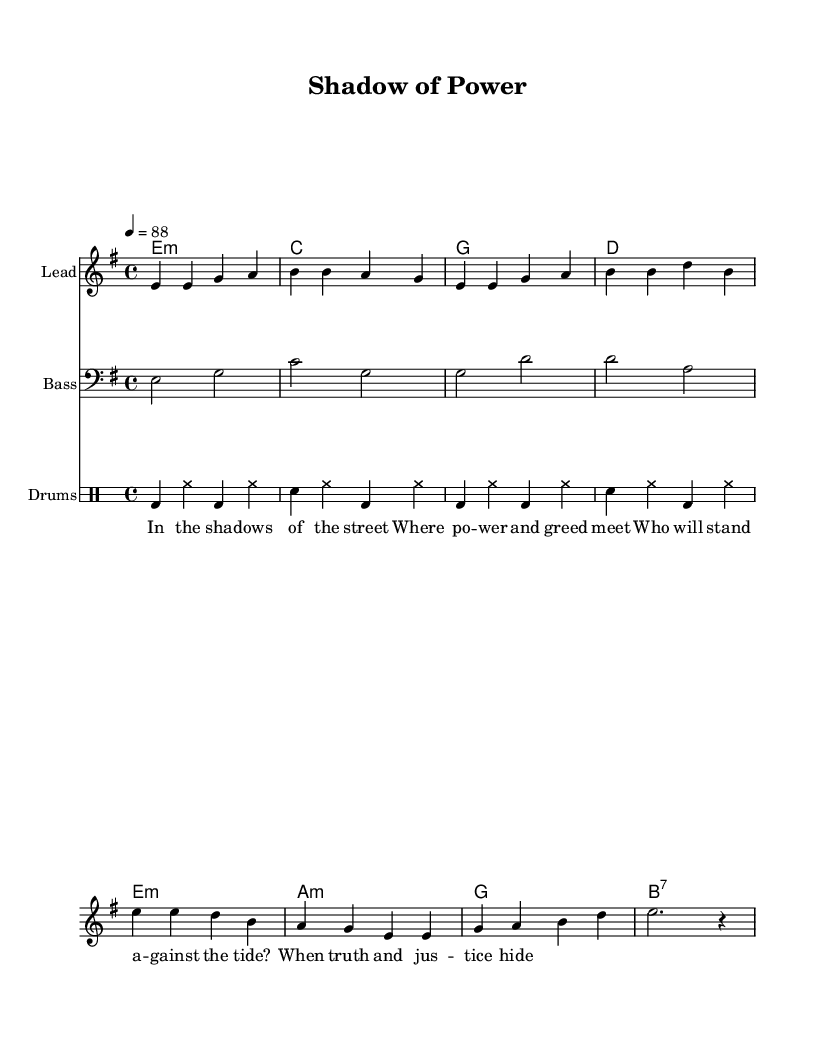What is the key signature of this music? The key signature is indicated with the "key" command in the global context. Here, it is shown as "e minor," which has one sharp (F#).
Answer: E minor What is the time signature of this piece? The time signature is indicated in the global context with the "time" command. It shows "4/4," meaning there are four beats in a measure, and the quarter note gets one beat.
Answer: 4/4 What is the tempo marking for this piece? The tempo is stated using the "tempo" command in the global context, which indicates a speed of "4 = 88," meaning there are 88 beats per minute.
Answer: 88 How many measures are there in the verse? The verse is notated clearly in the score, comprising four lines of music, with each line containing two measures. Thus, the total number of measures can be counted as 8.
Answer: 8 What are the chord names in the harmonies? The harmonies list each chord in the "harmonies" section, which are designated as "e minor, c, g, d, e minor, a minor, g, b7." Each chord corresponds to the progression played alongside the melody.
Answer: E minor, C, G, D, A minor, B7 In which section do the lyrics appear? The lyrics are placed in a new context labeled "Lyrics," and the lyrics themselves are written in lyric mode, demonstrating the sung portion of the music as aligned with the melody.
Answer: Lyrics What is the bass clef used in the score? In the "Bass" staff section, the clef is specified as the "bass" clef, which is indicated by the command "clef bass." This signifies that the instrument playing this staff will read lower pitches.
Answer: Bass 